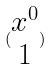<formula> <loc_0><loc_0><loc_500><loc_500>( \begin{matrix} x ^ { 0 } \\ 1 \end{matrix} )</formula> 